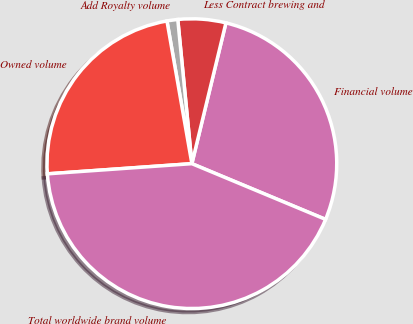Convert chart. <chart><loc_0><loc_0><loc_500><loc_500><pie_chart><fcel>Financial volume<fcel>Less Contract brewing and<fcel>Add Royalty volume<fcel>Owned volume<fcel>Total worldwide brand volume<nl><fcel>27.51%<fcel>5.33%<fcel>1.2%<fcel>23.37%<fcel>42.6%<nl></chart> 